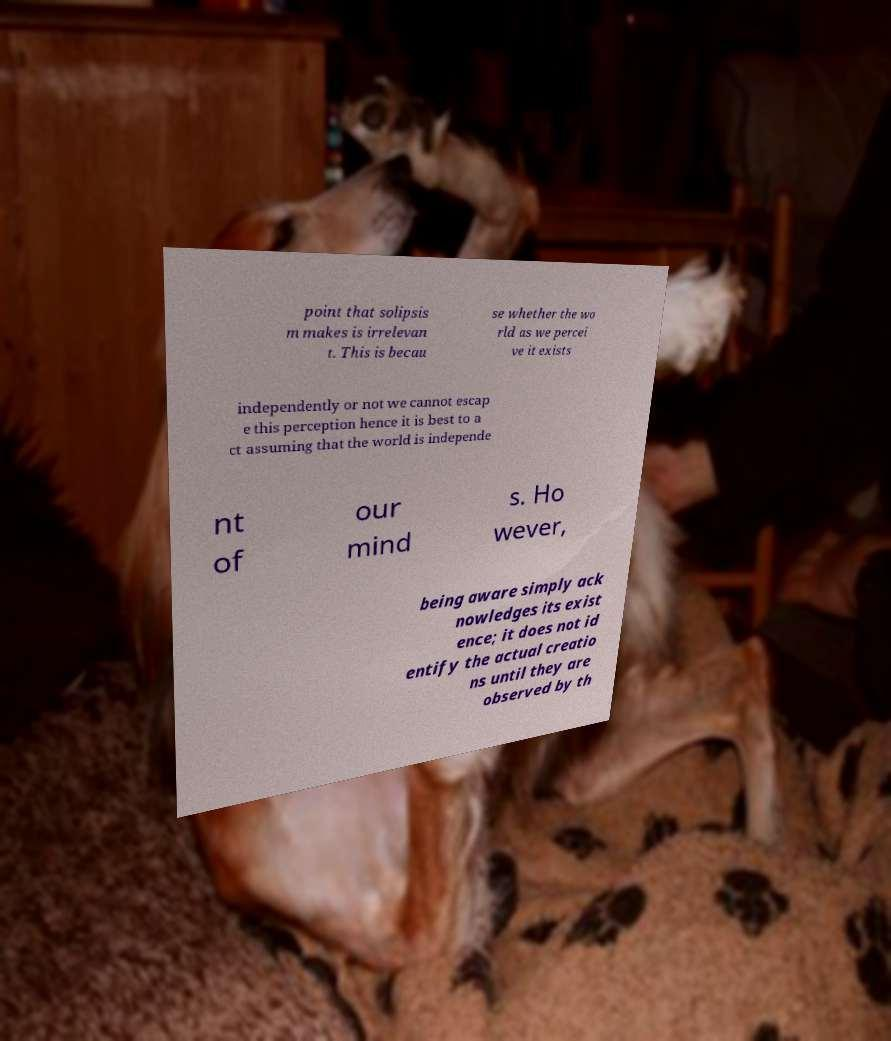I need the written content from this picture converted into text. Can you do that? point that solipsis m makes is irrelevan t. This is becau se whether the wo rld as we percei ve it exists independently or not we cannot escap e this perception hence it is best to a ct assuming that the world is independe nt of our mind s. Ho wever, being aware simply ack nowledges its exist ence; it does not id entify the actual creatio ns until they are observed by th 